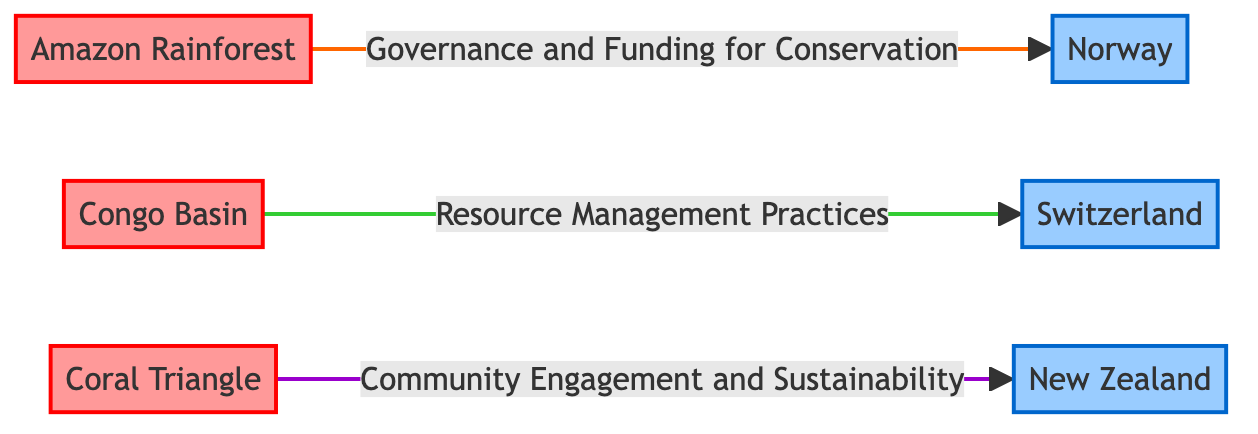What are the three biodiversity hotspots represented in the diagram? The diagram clearly shows three biodiversity hotspots: Amazon Rainforest, Congo Basin, and Coral Triangle, which are labeled in bold text.
Answer: Amazon Rainforest, Congo Basin, Coral Triangle How many political stability areas are identified in the diagram? There are three political stability areas represented in the diagram, namely Norway, Switzerland, and New Zealand, all distinguished by their class styling.
Answer: Three What relationship connects the Amazon Rainforest and Norway? The diagram shows a relationship labeled "Governance and Funding for Conservation" that connects the Amazon Rainforest to Norway, indicating a specific type of interaction between these nodes.
Answer: Governance and Funding for Conservation Which biodiversity hotspot is associated with resource management practices? The Congo Basin is associated with the relationship labeled "Resource Management Practices," which connects it to Switzerland in the diagram.
Answer: Congo Basin Which political stability area is related to community engagement and sustainability? The Coral Triangle is linked to New Zealand through the relationship labeled "Community Engagement and Sustainability," showcasing the associated practice.
Answer: New Zealand What color scheme represents biodiversity hotspots in the diagram? Biodiversity hotspots are colored in a light red shade (fill: #ff9999) according to the class definition specified in the code of the diagram.
Answer: Light red How many directed edges are there in total between the hotspot and stability nodes? The diagram contains three directed edges, each representing the relationship between one biodiversity hotspot and its corresponding political stability area.
Answer: Three Which hotspot connects to a political stability area through a sustainability-focused relationship? The Coral Triangle connects to New Zealand through the relationship labeled "Community Engagement and Sustainability," linking the hotspot to a politically stable region based on this focus.
Answer: Coral Triangle Why is the Congo Basin highlighted in the context of resource management? The Congo Basin's association with the resource management practices emphasizes its importance within the biodiversity hotspot framework, as depicted in the diagram's connection to Switzerland.
Answer: Resource management practices 